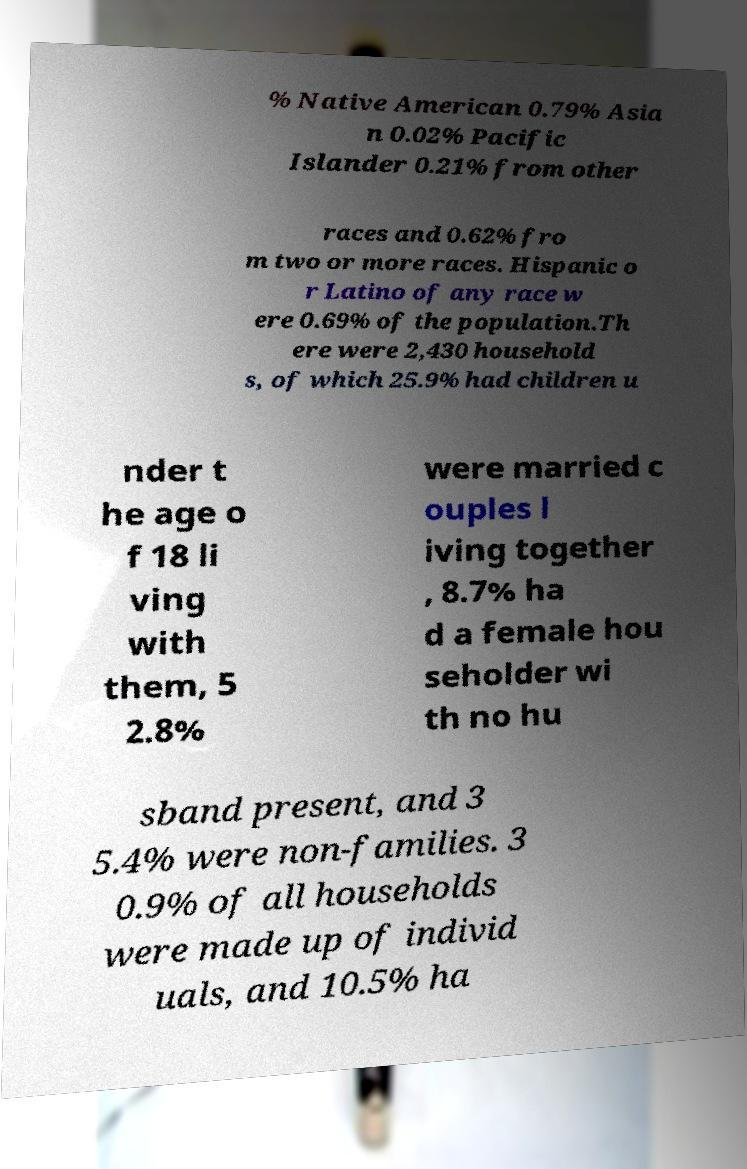Could you assist in decoding the text presented in this image and type it out clearly? % Native American 0.79% Asia n 0.02% Pacific Islander 0.21% from other races and 0.62% fro m two or more races. Hispanic o r Latino of any race w ere 0.69% of the population.Th ere were 2,430 household s, of which 25.9% had children u nder t he age o f 18 li ving with them, 5 2.8% were married c ouples l iving together , 8.7% ha d a female hou seholder wi th no hu sband present, and 3 5.4% were non-families. 3 0.9% of all households were made up of individ uals, and 10.5% ha 